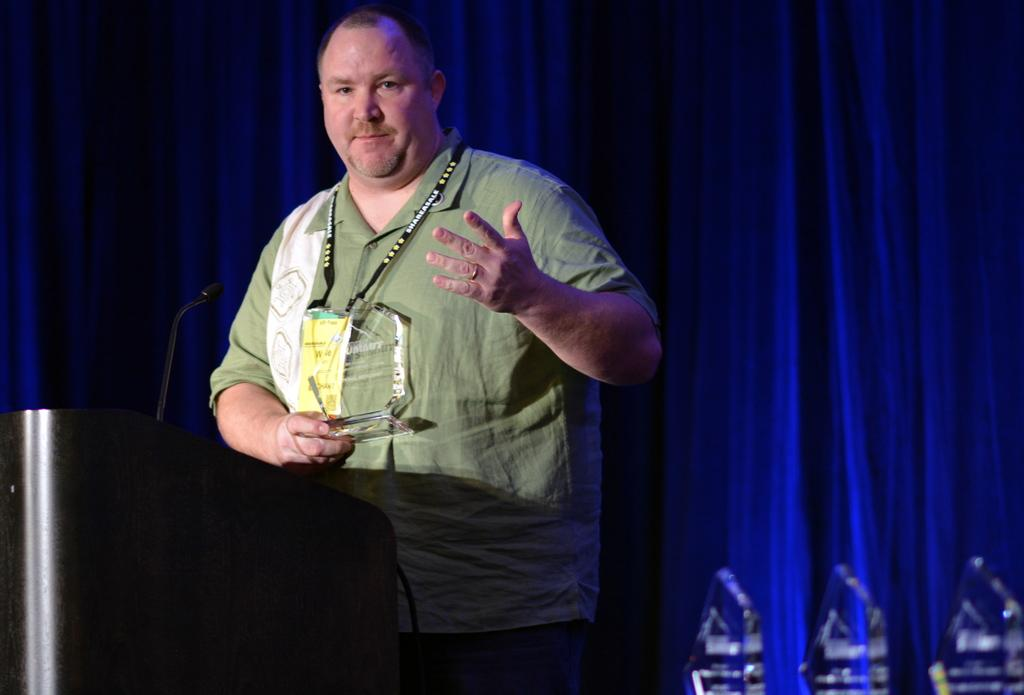Who is present in the image? There is a man in the image. What is the man wearing? The man is wearing a green shirt. What can be seen in the background of the image? There are blue curtains in the image. How would you describe the lighting in the image? The image appears to be slightly dark. What is the plot of the story being told by the crow in the image? There is no crow present in the image, and therefore no story being told by a crow. 